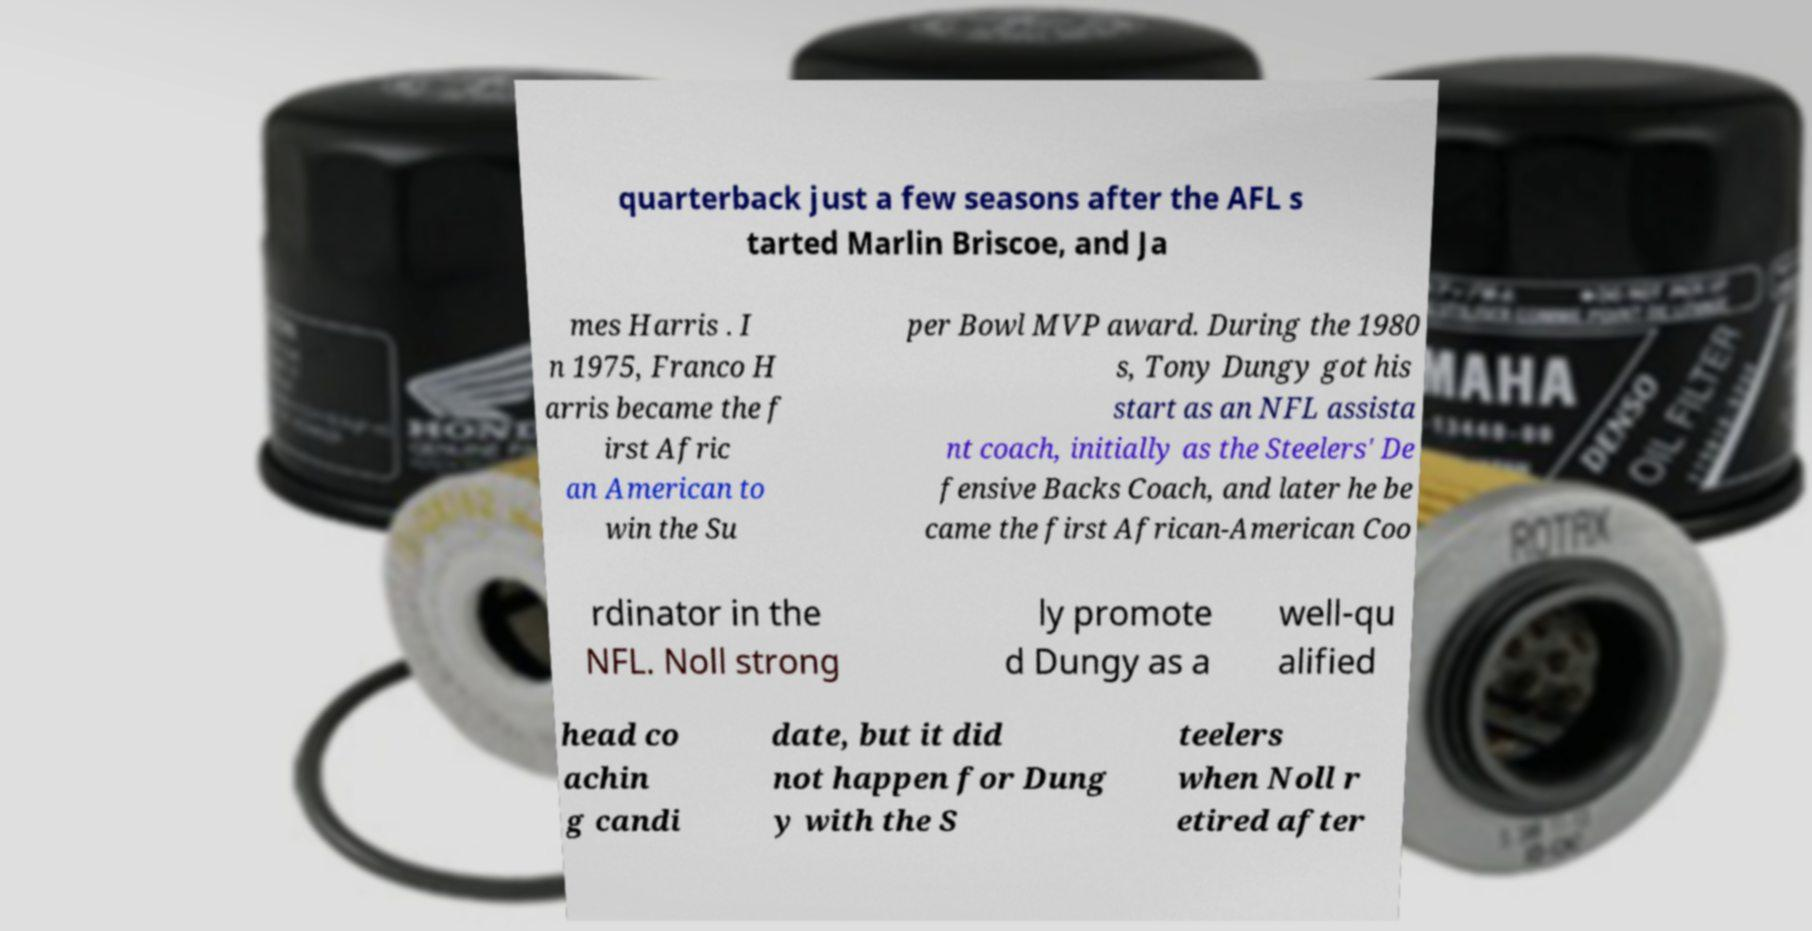Can you read and provide the text displayed in the image?This photo seems to have some interesting text. Can you extract and type it out for me? quarterback just a few seasons after the AFL s tarted Marlin Briscoe, and Ja mes Harris . I n 1975, Franco H arris became the f irst Afric an American to win the Su per Bowl MVP award. During the 1980 s, Tony Dungy got his start as an NFL assista nt coach, initially as the Steelers' De fensive Backs Coach, and later he be came the first African-American Coo rdinator in the NFL. Noll strong ly promote d Dungy as a well-qu alified head co achin g candi date, but it did not happen for Dung y with the S teelers when Noll r etired after 